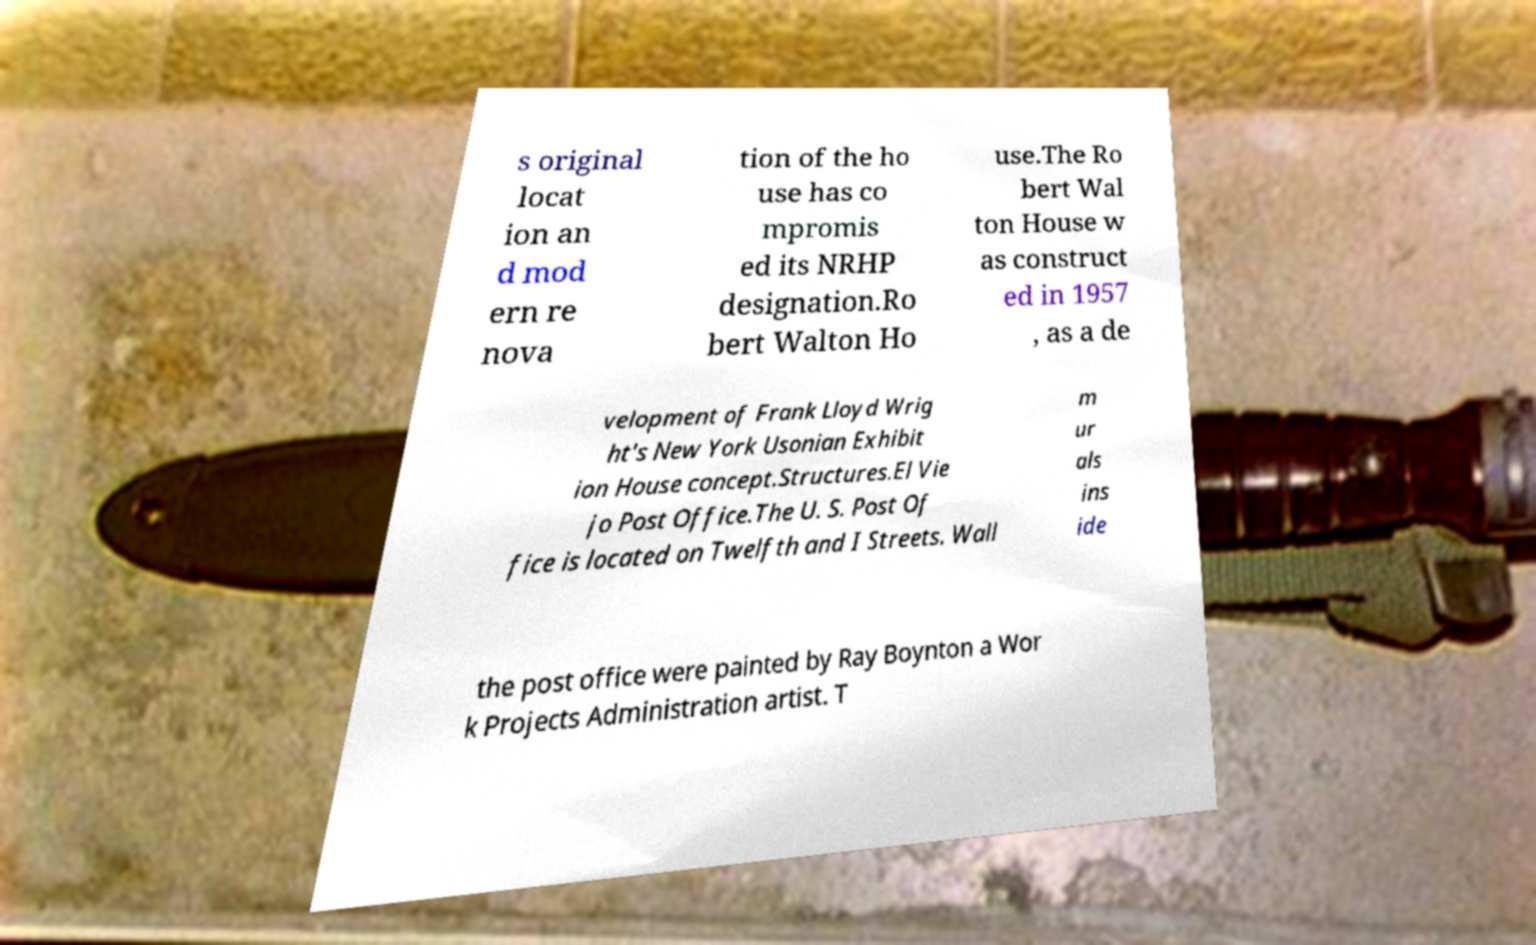What messages or text are displayed in this image? I need them in a readable, typed format. s original locat ion an d mod ern re nova tion of the ho use has co mpromis ed its NRHP designation.Ro bert Walton Ho use.The Ro bert Wal ton House w as construct ed in 1957 , as a de velopment of Frank Lloyd Wrig ht's New York Usonian Exhibit ion House concept.Structures.El Vie jo Post Office.The U. S. Post Of fice is located on Twelfth and I Streets. Wall m ur als ins ide the post office were painted by Ray Boynton a Wor k Projects Administration artist. T 